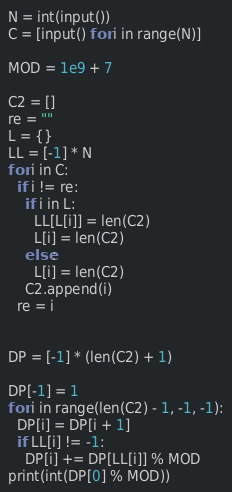<code> <loc_0><loc_0><loc_500><loc_500><_Python_>N = int(input())
C = [input() for i in range(N)]

MOD = 1e9 + 7

C2 = []
re = ""
L = {}
LL = [-1] * N
for i in C:
  if i != re:
    if i in L:
      LL[L[i]] = len(C2)
      L[i] = len(C2)
    else:
      L[i] = len(C2)
    C2.append(i)
  re = i


DP = [-1] * (len(C2) + 1)

DP[-1] = 1
for i in range(len(C2) - 1, -1, -1):
  DP[i] = DP[i + 1]
  if LL[i] != -1:
    DP[i] += DP[LL[i]] % MOD
print(int(DP[0] % MOD))
</code> 